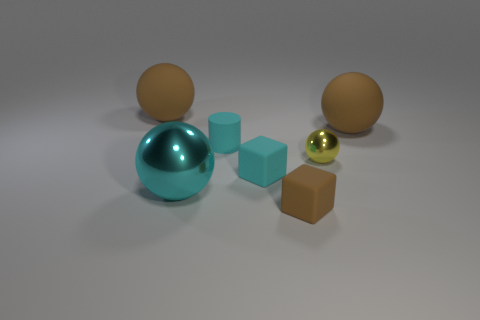What can the shadows tell us about the light source in the image? The shadows are soft and extend evenly in one direction, suggesting a single, diffused light source located on the opposite side, illuminating the scene from above and creating subtle shadowing that helps to give depth to the objects. Could the arrangement of these objects tell a story or convey a concept? Certainly, the arrangement of these objects might represent a variety of concepts. For example, it could depict balance, with the objects differing in size and texture but arranged in a harmonious composition. Alternatively, it can be seen as a representation of diversity or individuality, where each object stands out with its unique shape and material. 